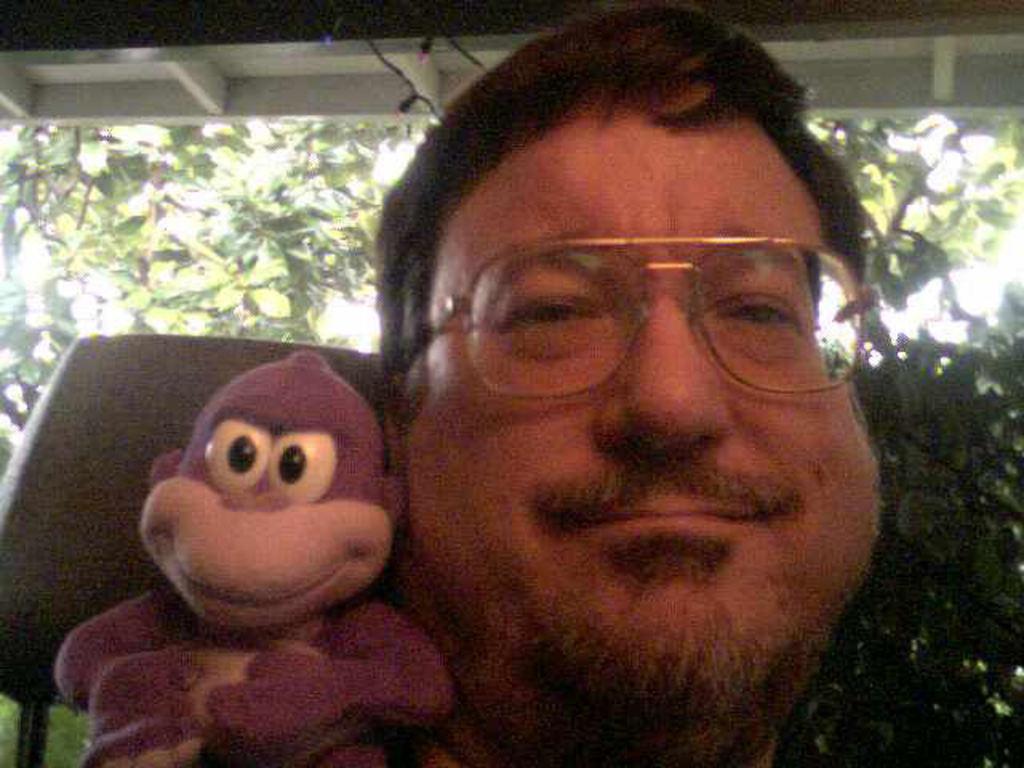Please provide a concise description of this image. In this image there is a person smiling and holding a toy , at the back ground there is tree, sky, building. 